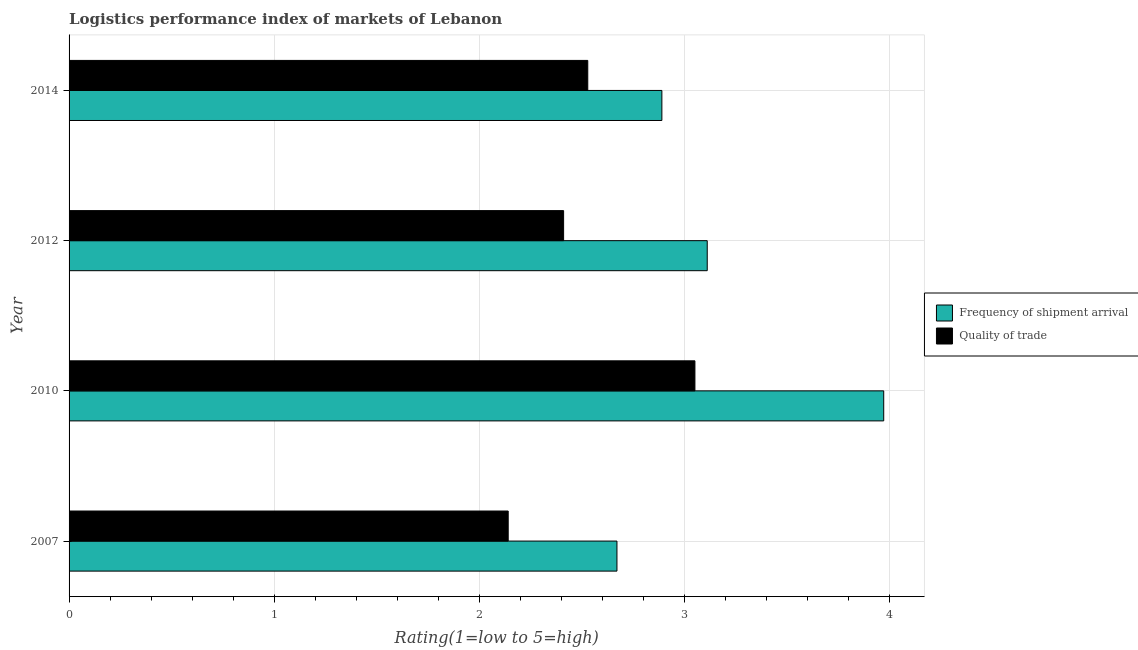How many bars are there on the 1st tick from the top?
Offer a terse response. 2. How many bars are there on the 4th tick from the bottom?
Keep it short and to the point. 2. What is the label of the 2nd group of bars from the top?
Make the answer very short. 2012. What is the lpi quality of trade in 2007?
Offer a very short reply. 2.14. Across all years, what is the maximum lpi of frequency of shipment arrival?
Ensure brevity in your answer.  3.97. Across all years, what is the minimum lpi of frequency of shipment arrival?
Provide a succinct answer. 2.67. What is the total lpi of frequency of shipment arrival in the graph?
Ensure brevity in your answer.  12.64. What is the difference between the lpi quality of trade in 2010 and that in 2014?
Give a very brief answer. 0.52. What is the difference between the lpi quality of trade in 2012 and the lpi of frequency of shipment arrival in 2014?
Provide a short and direct response. -0.48. What is the average lpi of frequency of shipment arrival per year?
Provide a short and direct response. 3.16. In how many years, is the lpi of frequency of shipment arrival greater than 3.6 ?
Provide a short and direct response. 1. What is the ratio of the lpi quality of trade in 2007 to that in 2010?
Ensure brevity in your answer.  0.7. Is the lpi quality of trade in 2007 less than that in 2010?
Ensure brevity in your answer.  Yes. What is the difference between the highest and the second highest lpi quality of trade?
Offer a very short reply. 0.52. What is the difference between the highest and the lowest lpi quality of trade?
Keep it short and to the point. 0.91. In how many years, is the lpi of frequency of shipment arrival greater than the average lpi of frequency of shipment arrival taken over all years?
Your answer should be compact. 1. Is the sum of the lpi quality of trade in 2012 and 2014 greater than the maximum lpi of frequency of shipment arrival across all years?
Your answer should be very brief. Yes. What does the 1st bar from the top in 2010 represents?
Your response must be concise. Quality of trade. What does the 1st bar from the bottom in 2007 represents?
Make the answer very short. Frequency of shipment arrival. How many bars are there?
Your answer should be compact. 8. Are all the bars in the graph horizontal?
Make the answer very short. Yes. How are the legend labels stacked?
Give a very brief answer. Vertical. What is the title of the graph?
Make the answer very short. Logistics performance index of markets of Lebanon. What is the label or title of the X-axis?
Keep it short and to the point. Rating(1=low to 5=high). What is the Rating(1=low to 5=high) in Frequency of shipment arrival in 2007?
Your response must be concise. 2.67. What is the Rating(1=low to 5=high) in Quality of trade in 2007?
Keep it short and to the point. 2.14. What is the Rating(1=low to 5=high) of Frequency of shipment arrival in 2010?
Ensure brevity in your answer.  3.97. What is the Rating(1=low to 5=high) of Quality of trade in 2010?
Your answer should be very brief. 3.05. What is the Rating(1=low to 5=high) in Frequency of shipment arrival in 2012?
Your response must be concise. 3.11. What is the Rating(1=low to 5=high) of Quality of trade in 2012?
Ensure brevity in your answer.  2.41. What is the Rating(1=low to 5=high) in Frequency of shipment arrival in 2014?
Provide a short and direct response. 2.89. What is the Rating(1=low to 5=high) in Quality of trade in 2014?
Your answer should be compact. 2.53. Across all years, what is the maximum Rating(1=low to 5=high) of Frequency of shipment arrival?
Offer a terse response. 3.97. Across all years, what is the maximum Rating(1=low to 5=high) in Quality of trade?
Ensure brevity in your answer.  3.05. Across all years, what is the minimum Rating(1=low to 5=high) in Frequency of shipment arrival?
Keep it short and to the point. 2.67. Across all years, what is the minimum Rating(1=low to 5=high) of Quality of trade?
Provide a succinct answer. 2.14. What is the total Rating(1=low to 5=high) in Frequency of shipment arrival in the graph?
Keep it short and to the point. 12.64. What is the total Rating(1=low to 5=high) in Quality of trade in the graph?
Your answer should be compact. 10.13. What is the difference between the Rating(1=low to 5=high) of Quality of trade in 2007 and that in 2010?
Your response must be concise. -0.91. What is the difference between the Rating(1=low to 5=high) in Frequency of shipment arrival in 2007 and that in 2012?
Provide a succinct answer. -0.44. What is the difference between the Rating(1=low to 5=high) of Quality of trade in 2007 and that in 2012?
Make the answer very short. -0.27. What is the difference between the Rating(1=low to 5=high) in Frequency of shipment arrival in 2007 and that in 2014?
Offer a terse response. -0.22. What is the difference between the Rating(1=low to 5=high) of Quality of trade in 2007 and that in 2014?
Your answer should be compact. -0.39. What is the difference between the Rating(1=low to 5=high) of Frequency of shipment arrival in 2010 and that in 2012?
Offer a very short reply. 0.86. What is the difference between the Rating(1=low to 5=high) of Quality of trade in 2010 and that in 2012?
Give a very brief answer. 0.64. What is the difference between the Rating(1=low to 5=high) in Frequency of shipment arrival in 2010 and that in 2014?
Your answer should be compact. 1.08. What is the difference between the Rating(1=low to 5=high) in Quality of trade in 2010 and that in 2014?
Give a very brief answer. 0.52. What is the difference between the Rating(1=low to 5=high) in Frequency of shipment arrival in 2012 and that in 2014?
Your response must be concise. 0.22. What is the difference between the Rating(1=low to 5=high) in Quality of trade in 2012 and that in 2014?
Make the answer very short. -0.12. What is the difference between the Rating(1=low to 5=high) of Frequency of shipment arrival in 2007 and the Rating(1=low to 5=high) of Quality of trade in 2010?
Offer a very short reply. -0.38. What is the difference between the Rating(1=low to 5=high) in Frequency of shipment arrival in 2007 and the Rating(1=low to 5=high) in Quality of trade in 2012?
Offer a very short reply. 0.26. What is the difference between the Rating(1=low to 5=high) of Frequency of shipment arrival in 2007 and the Rating(1=low to 5=high) of Quality of trade in 2014?
Give a very brief answer. 0.14. What is the difference between the Rating(1=low to 5=high) of Frequency of shipment arrival in 2010 and the Rating(1=low to 5=high) of Quality of trade in 2012?
Your answer should be very brief. 1.56. What is the difference between the Rating(1=low to 5=high) in Frequency of shipment arrival in 2010 and the Rating(1=low to 5=high) in Quality of trade in 2014?
Provide a succinct answer. 1.44. What is the difference between the Rating(1=low to 5=high) of Frequency of shipment arrival in 2012 and the Rating(1=low to 5=high) of Quality of trade in 2014?
Keep it short and to the point. 0.58. What is the average Rating(1=low to 5=high) of Frequency of shipment arrival per year?
Ensure brevity in your answer.  3.16. What is the average Rating(1=low to 5=high) of Quality of trade per year?
Provide a succinct answer. 2.53. In the year 2007, what is the difference between the Rating(1=low to 5=high) in Frequency of shipment arrival and Rating(1=low to 5=high) in Quality of trade?
Offer a terse response. 0.53. In the year 2014, what is the difference between the Rating(1=low to 5=high) in Frequency of shipment arrival and Rating(1=low to 5=high) in Quality of trade?
Your answer should be very brief. 0.36. What is the ratio of the Rating(1=low to 5=high) in Frequency of shipment arrival in 2007 to that in 2010?
Provide a succinct answer. 0.67. What is the ratio of the Rating(1=low to 5=high) of Quality of trade in 2007 to that in 2010?
Offer a very short reply. 0.7. What is the ratio of the Rating(1=low to 5=high) in Frequency of shipment arrival in 2007 to that in 2012?
Your response must be concise. 0.86. What is the ratio of the Rating(1=low to 5=high) in Quality of trade in 2007 to that in 2012?
Your response must be concise. 0.89. What is the ratio of the Rating(1=low to 5=high) of Frequency of shipment arrival in 2007 to that in 2014?
Ensure brevity in your answer.  0.92. What is the ratio of the Rating(1=low to 5=high) in Quality of trade in 2007 to that in 2014?
Give a very brief answer. 0.85. What is the ratio of the Rating(1=low to 5=high) of Frequency of shipment arrival in 2010 to that in 2012?
Provide a succinct answer. 1.28. What is the ratio of the Rating(1=low to 5=high) of Quality of trade in 2010 to that in 2012?
Offer a very short reply. 1.27. What is the ratio of the Rating(1=low to 5=high) in Frequency of shipment arrival in 2010 to that in 2014?
Keep it short and to the point. 1.37. What is the ratio of the Rating(1=low to 5=high) in Quality of trade in 2010 to that in 2014?
Your answer should be compact. 1.21. What is the ratio of the Rating(1=low to 5=high) in Frequency of shipment arrival in 2012 to that in 2014?
Your response must be concise. 1.08. What is the ratio of the Rating(1=low to 5=high) of Quality of trade in 2012 to that in 2014?
Keep it short and to the point. 0.95. What is the difference between the highest and the second highest Rating(1=low to 5=high) in Frequency of shipment arrival?
Make the answer very short. 0.86. What is the difference between the highest and the second highest Rating(1=low to 5=high) of Quality of trade?
Provide a succinct answer. 0.52. What is the difference between the highest and the lowest Rating(1=low to 5=high) in Quality of trade?
Offer a very short reply. 0.91. 